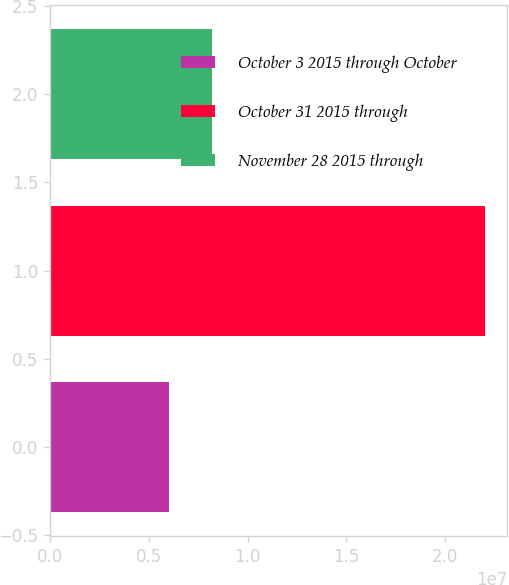Convert chart to OTSL. <chart><loc_0><loc_0><loc_500><loc_500><bar_chart><fcel>October 3 2015 through October<fcel>October 31 2015 through<fcel>November 28 2015 through<nl><fcel>6.0242e+06<fcel>2.20273e+07<fcel>8.20973e+06<nl></chart> 